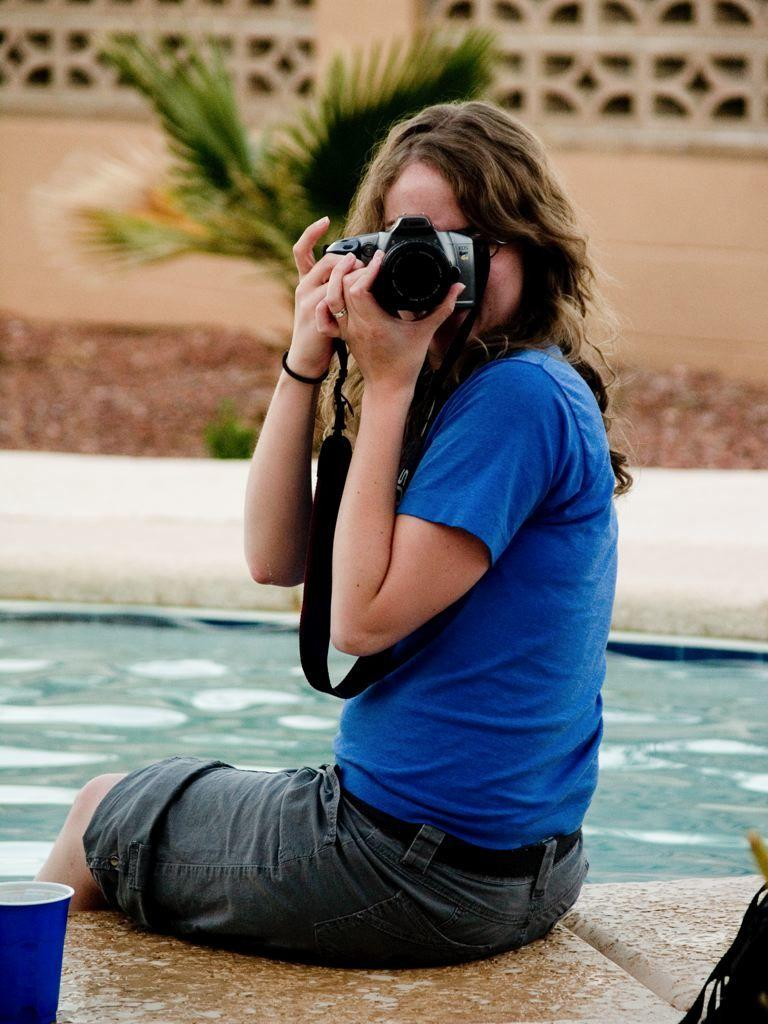Who is present in the image? There is a woman in the image. What is the woman holding? The woman is holding a camera. Where is the woman sitting? The woman is sitting in front of a pool. What can be seen in the image besides the woman and the pool? There is a cup in the image. What type of vegetation is visible in the background of the image? There are plants in the background of the image. What type of apple is being eaten in the lunchroom in the image? There is no apple or lunchroom present in the image; it features a woman sitting in front of a pool with a camera, a cup, and plants in the background. 